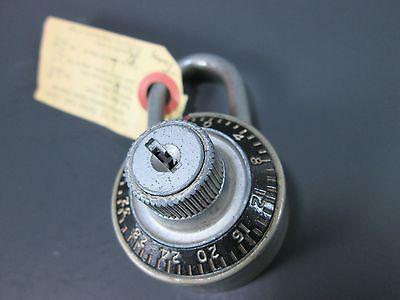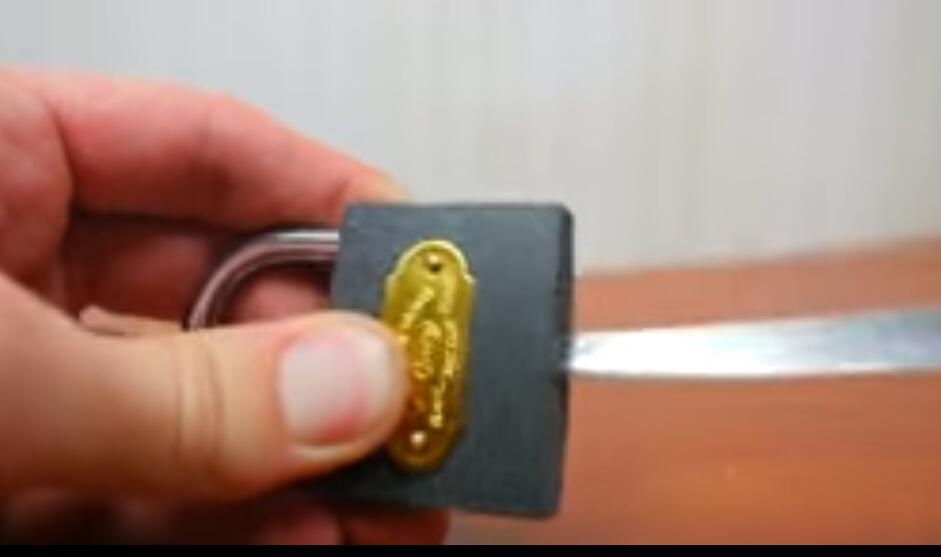The first image is the image on the left, the second image is the image on the right. For the images shown, is this caption "The left image shows a hand holding a pointed object that is not inserted in the lock's keyhole." true? Answer yes or no. No. 